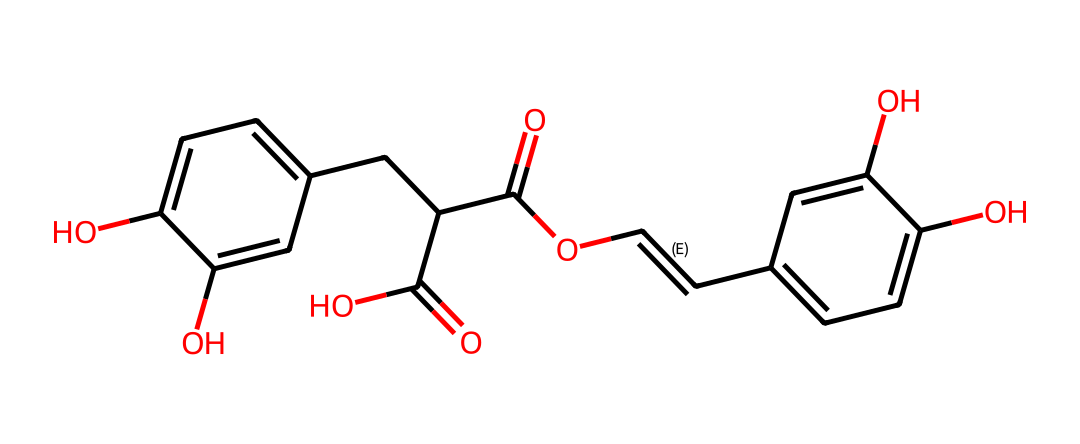What is the molecular formula of rosmarinic acid? To determine the molecular formula, we count the number of each type of atom present in the SMILES representation. The chemical does not explicitly show hydrogen atoms, but we infer them based on the tetravalent nature of carbon. After analyzing the structure, we find there are 18 carbon atoms, 16 hydrogen atoms, and 4 oxygen atoms, leading to the formula C18H16O4.
Answer: C18H16O4 How many hydroxyl (–OH) groups are present in rosmarinic acid? The presence of hydroxyl groups can be recognized through the "O" connected to a carbon without being doubly bonded, which indicates a –OH group. From the structure, we can identify two such groups in the phenolic rings of the compound.
Answer: 2 What type of chemical interaction might rosmarinic acid primarily exhibit due to its structure? Given the presence of hydroxyl groups and carbonyl functionalities in the structure, rosmarinic acid is likely to exhibit hydrogen bonding interactions. The ability of –OH groups to form hydrogen bonds allows it to engage in solvation and binding with various biomolecules.
Answer: hydrogen bonding Is rosmarinic acid classified as a phenolic compound? Yes, phenolic compounds typically contain hydroxyl groups attached directly to an aromatic hydrocarbon group. Since rosmarinic acid has two aromatic rings with hydroxyl substituents, it falls into the category of phenolic compounds.
Answer: yes What type of antioxidant properties does rosmarinic acid have? Rosmarinic acid's structure, with multiple hydroxyl groups and other functionalities, suggests it acts as a free radical scavenger. It can donate hydrogen atoms to free radicals, thereby reducing oxidative stress in biological systems.
Answer: free radical scavenger How many double bonds are present in the molecular structure of rosmarinic acid? To find the double bonds, we examine the structure for "=" symbols between the carbon atoms. The analysis reveals two double bonds that connect carbons within the diene structure of the compound.
Answer: 2 